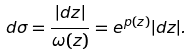<formula> <loc_0><loc_0><loc_500><loc_500>d \sigma = \frac { | d z | } { \omega ( z ) } = e ^ { p ( z ) } | d z | .</formula> 